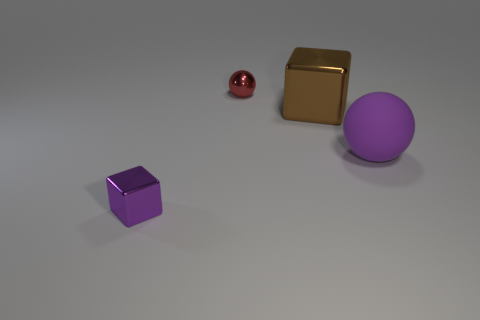Are the brown block and the red thing made of the same material?
Your answer should be very brief. Yes. What material is the tiny sphere?
Provide a short and direct response. Metal. What is the size of the red metal thing?
Your answer should be very brief. Small. Is the purple ball the same size as the purple metallic thing?
Offer a terse response. No. There is a sphere behind the large cube; what is its material?
Your answer should be very brief. Metal. There is another object that is the same shape as the tiny purple metallic object; what is it made of?
Give a very brief answer. Metal. Are there any large balls right of the large rubber sphere that is in front of the small red sphere?
Provide a short and direct response. No. Is the shape of the tiny purple shiny object the same as the small red object?
Your response must be concise. No. What shape is the brown thing that is the same material as the purple cube?
Offer a terse response. Cube. Do the ball that is on the right side of the tiny metallic ball and the metal object that is on the left side of the shiny sphere have the same size?
Give a very brief answer. No. 